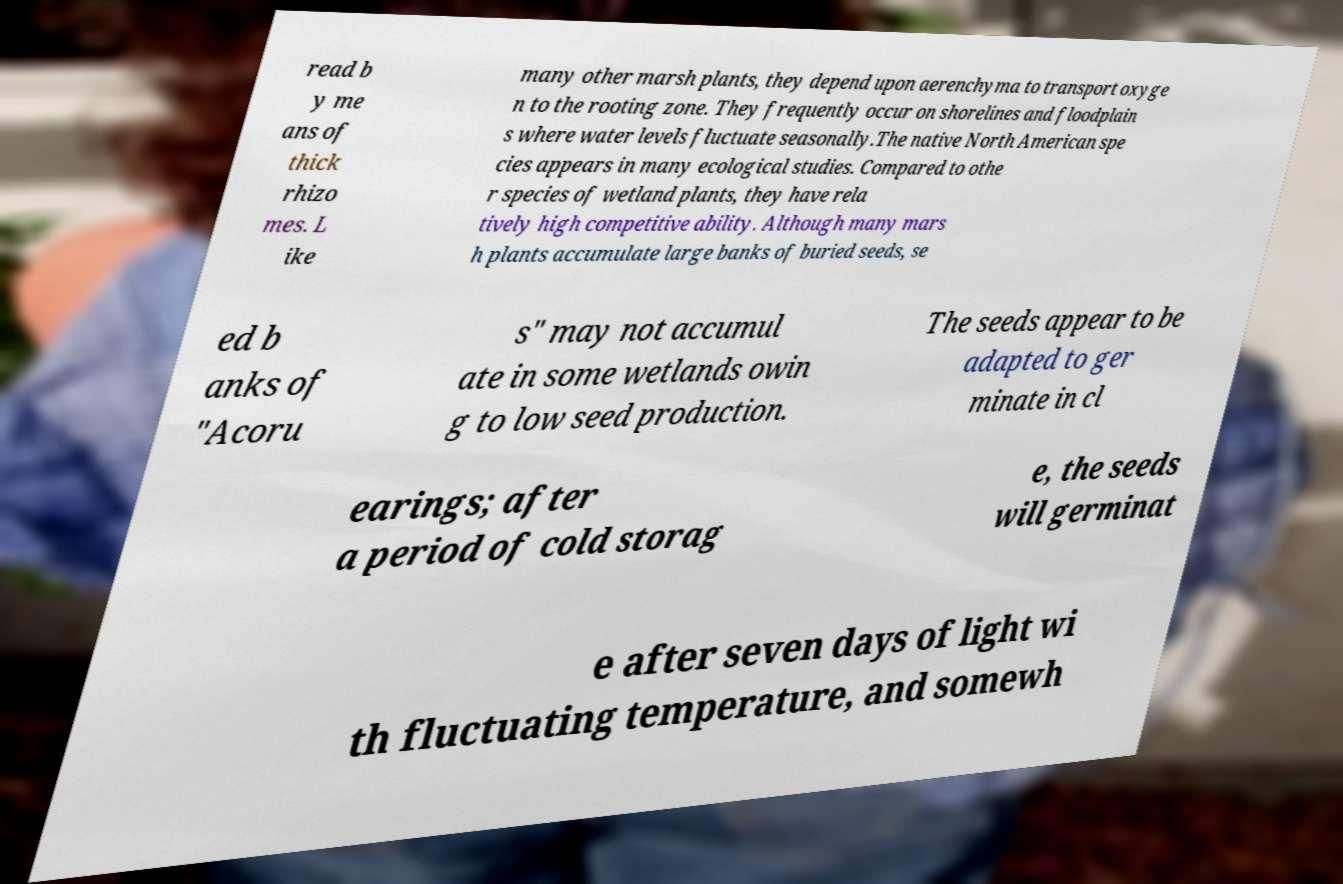Can you accurately transcribe the text from the provided image for me? read b y me ans of thick rhizo mes. L ike many other marsh plants, they depend upon aerenchyma to transport oxyge n to the rooting zone. They frequently occur on shorelines and floodplain s where water levels fluctuate seasonally.The native North American spe cies appears in many ecological studies. Compared to othe r species of wetland plants, they have rela tively high competitive ability. Although many mars h plants accumulate large banks of buried seeds, se ed b anks of "Acoru s" may not accumul ate in some wetlands owin g to low seed production. The seeds appear to be adapted to ger minate in cl earings; after a period of cold storag e, the seeds will germinat e after seven days of light wi th fluctuating temperature, and somewh 